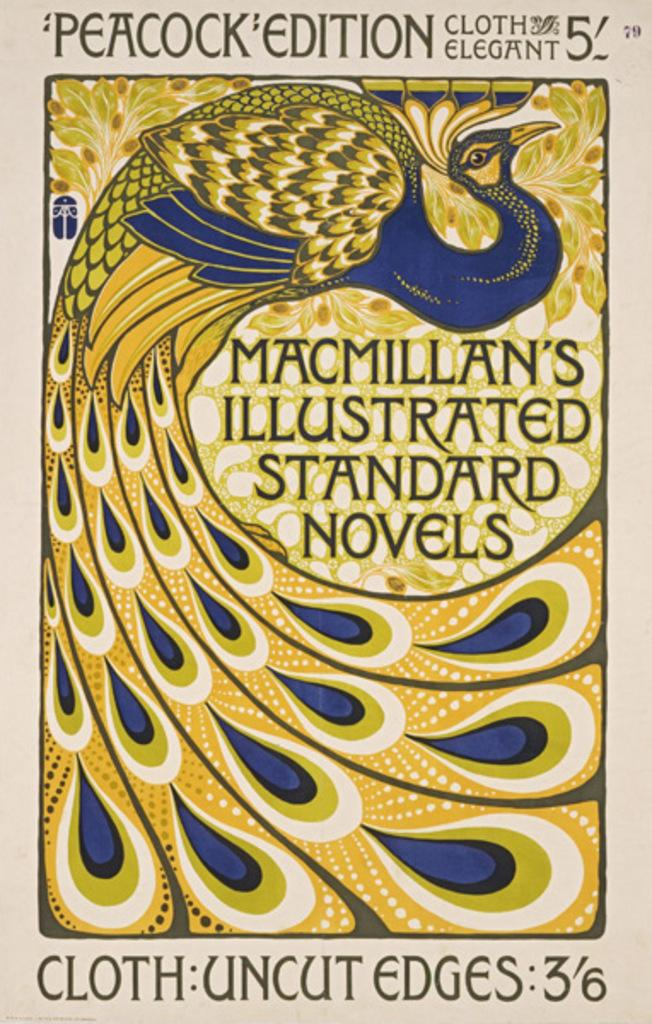<image>
Present a compact description of the photo's key features. A book cover for Peacock edition cloth elegant 5 titled Macmillan's Illustrated Standard novels featuring a blue and gold peacock design. 